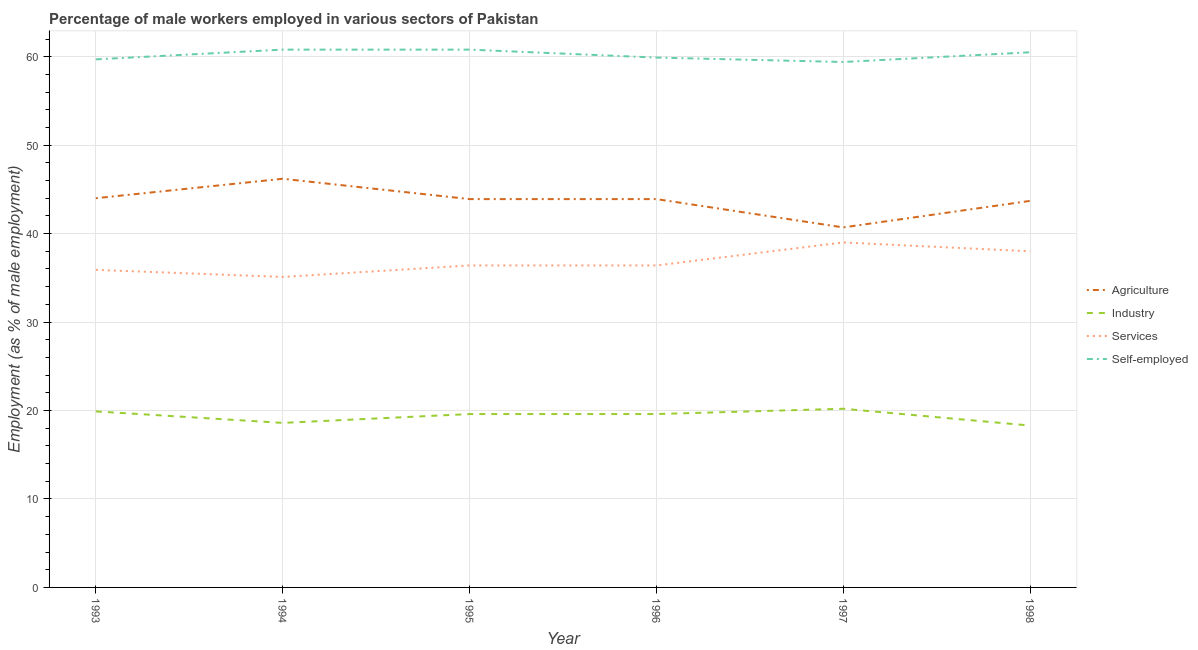Across all years, what is the maximum percentage of male workers in agriculture?
Give a very brief answer. 46.2. Across all years, what is the minimum percentage of self employed male workers?
Provide a succinct answer. 59.4. In which year was the percentage of male workers in services minimum?
Keep it short and to the point. 1994. What is the total percentage of self employed male workers in the graph?
Your answer should be compact. 361.1. What is the difference between the percentage of male workers in services in 1994 and that in 1996?
Provide a succinct answer. -1.3. What is the difference between the percentage of male workers in services in 1997 and the percentage of male workers in agriculture in 1994?
Keep it short and to the point. -7.2. What is the average percentage of male workers in services per year?
Ensure brevity in your answer.  36.8. In the year 1995, what is the difference between the percentage of male workers in industry and percentage of male workers in services?
Offer a terse response. -16.8. What is the ratio of the percentage of male workers in services in 1997 to that in 1998?
Your answer should be compact. 1.03. Is the percentage of male workers in agriculture in 1996 less than that in 1998?
Your answer should be compact. No. Is the difference between the percentage of male workers in services in 1994 and 1998 greater than the difference between the percentage of male workers in industry in 1994 and 1998?
Offer a terse response. No. What is the difference between the highest and the second highest percentage of male workers in industry?
Provide a short and direct response. 0.3. What is the difference between the highest and the lowest percentage of male workers in industry?
Your response must be concise. 1.9. Is the percentage of male workers in services strictly greater than the percentage of male workers in industry over the years?
Your response must be concise. Yes. Does the graph contain grids?
Offer a very short reply. Yes. How many legend labels are there?
Keep it short and to the point. 4. How are the legend labels stacked?
Ensure brevity in your answer.  Vertical. What is the title of the graph?
Give a very brief answer. Percentage of male workers employed in various sectors of Pakistan. What is the label or title of the Y-axis?
Your answer should be compact. Employment (as % of male employment). What is the Employment (as % of male employment) of Agriculture in 1993?
Your answer should be compact. 44. What is the Employment (as % of male employment) of Industry in 1993?
Keep it short and to the point. 19.9. What is the Employment (as % of male employment) in Services in 1993?
Your answer should be very brief. 35.9. What is the Employment (as % of male employment) of Self-employed in 1993?
Your answer should be compact. 59.7. What is the Employment (as % of male employment) of Agriculture in 1994?
Make the answer very short. 46.2. What is the Employment (as % of male employment) of Industry in 1994?
Keep it short and to the point. 18.6. What is the Employment (as % of male employment) in Services in 1994?
Offer a terse response. 35.1. What is the Employment (as % of male employment) in Self-employed in 1994?
Offer a terse response. 60.8. What is the Employment (as % of male employment) of Agriculture in 1995?
Your response must be concise. 43.9. What is the Employment (as % of male employment) in Industry in 1995?
Your answer should be very brief. 19.6. What is the Employment (as % of male employment) of Services in 1995?
Keep it short and to the point. 36.4. What is the Employment (as % of male employment) in Self-employed in 1995?
Offer a terse response. 60.8. What is the Employment (as % of male employment) of Agriculture in 1996?
Your answer should be very brief. 43.9. What is the Employment (as % of male employment) in Industry in 1996?
Your answer should be very brief. 19.6. What is the Employment (as % of male employment) in Services in 1996?
Your answer should be compact. 36.4. What is the Employment (as % of male employment) in Self-employed in 1996?
Give a very brief answer. 59.9. What is the Employment (as % of male employment) of Agriculture in 1997?
Keep it short and to the point. 40.7. What is the Employment (as % of male employment) of Industry in 1997?
Offer a terse response. 20.2. What is the Employment (as % of male employment) of Self-employed in 1997?
Keep it short and to the point. 59.4. What is the Employment (as % of male employment) of Agriculture in 1998?
Provide a short and direct response. 43.7. What is the Employment (as % of male employment) in Industry in 1998?
Make the answer very short. 18.3. What is the Employment (as % of male employment) in Services in 1998?
Offer a very short reply. 38. What is the Employment (as % of male employment) in Self-employed in 1998?
Offer a very short reply. 60.5. Across all years, what is the maximum Employment (as % of male employment) in Agriculture?
Your answer should be very brief. 46.2. Across all years, what is the maximum Employment (as % of male employment) of Industry?
Provide a short and direct response. 20.2. Across all years, what is the maximum Employment (as % of male employment) of Self-employed?
Provide a short and direct response. 60.8. Across all years, what is the minimum Employment (as % of male employment) in Agriculture?
Your answer should be very brief. 40.7. Across all years, what is the minimum Employment (as % of male employment) in Industry?
Make the answer very short. 18.3. Across all years, what is the minimum Employment (as % of male employment) in Services?
Provide a succinct answer. 35.1. Across all years, what is the minimum Employment (as % of male employment) in Self-employed?
Offer a very short reply. 59.4. What is the total Employment (as % of male employment) of Agriculture in the graph?
Your answer should be compact. 262.4. What is the total Employment (as % of male employment) in Industry in the graph?
Make the answer very short. 116.2. What is the total Employment (as % of male employment) of Services in the graph?
Your response must be concise. 220.8. What is the total Employment (as % of male employment) in Self-employed in the graph?
Ensure brevity in your answer.  361.1. What is the difference between the Employment (as % of male employment) in Agriculture in 1993 and that in 1994?
Give a very brief answer. -2.2. What is the difference between the Employment (as % of male employment) of Services in 1993 and that in 1994?
Make the answer very short. 0.8. What is the difference between the Employment (as % of male employment) in Agriculture in 1993 and that in 1995?
Ensure brevity in your answer.  0.1. What is the difference between the Employment (as % of male employment) in Industry in 1993 and that in 1995?
Provide a succinct answer. 0.3. What is the difference between the Employment (as % of male employment) of Services in 1993 and that in 1995?
Your answer should be very brief. -0.5. What is the difference between the Employment (as % of male employment) of Agriculture in 1993 and that in 1996?
Give a very brief answer. 0.1. What is the difference between the Employment (as % of male employment) in Industry in 1993 and that in 1996?
Offer a very short reply. 0.3. What is the difference between the Employment (as % of male employment) in Services in 1993 and that in 1996?
Offer a terse response. -0.5. What is the difference between the Employment (as % of male employment) of Agriculture in 1993 and that in 1997?
Your answer should be compact. 3.3. What is the difference between the Employment (as % of male employment) in Industry in 1993 and that in 1997?
Provide a short and direct response. -0.3. What is the difference between the Employment (as % of male employment) in Industry in 1994 and that in 1995?
Provide a short and direct response. -1. What is the difference between the Employment (as % of male employment) in Industry in 1994 and that in 1996?
Your answer should be compact. -1. What is the difference between the Employment (as % of male employment) in Self-employed in 1994 and that in 1996?
Offer a terse response. 0.9. What is the difference between the Employment (as % of male employment) in Services in 1994 and that in 1997?
Offer a terse response. -3.9. What is the difference between the Employment (as % of male employment) in Self-employed in 1994 and that in 1997?
Provide a short and direct response. 1.4. What is the difference between the Employment (as % of male employment) of Industry in 1994 and that in 1998?
Your answer should be compact. 0.3. What is the difference between the Employment (as % of male employment) in Services in 1994 and that in 1998?
Make the answer very short. -2.9. What is the difference between the Employment (as % of male employment) of Self-employed in 1994 and that in 1998?
Offer a terse response. 0.3. What is the difference between the Employment (as % of male employment) of Agriculture in 1995 and that in 1996?
Make the answer very short. 0. What is the difference between the Employment (as % of male employment) of Agriculture in 1995 and that in 1997?
Your answer should be very brief. 3.2. What is the difference between the Employment (as % of male employment) of Services in 1995 and that in 1997?
Provide a short and direct response. -2.6. What is the difference between the Employment (as % of male employment) in Self-employed in 1995 and that in 1997?
Provide a short and direct response. 1.4. What is the difference between the Employment (as % of male employment) of Agriculture in 1995 and that in 1998?
Offer a terse response. 0.2. What is the difference between the Employment (as % of male employment) of Industry in 1995 and that in 1998?
Give a very brief answer. 1.3. What is the difference between the Employment (as % of male employment) in Self-employed in 1995 and that in 1998?
Make the answer very short. 0.3. What is the difference between the Employment (as % of male employment) of Agriculture in 1996 and that in 1997?
Keep it short and to the point. 3.2. What is the difference between the Employment (as % of male employment) in Industry in 1996 and that in 1997?
Give a very brief answer. -0.6. What is the difference between the Employment (as % of male employment) in Services in 1996 and that in 1997?
Keep it short and to the point. -2.6. What is the difference between the Employment (as % of male employment) of Self-employed in 1996 and that in 1997?
Your response must be concise. 0.5. What is the difference between the Employment (as % of male employment) of Agriculture in 1996 and that in 1998?
Your answer should be very brief. 0.2. What is the difference between the Employment (as % of male employment) in Industry in 1996 and that in 1998?
Keep it short and to the point. 1.3. What is the difference between the Employment (as % of male employment) in Self-employed in 1996 and that in 1998?
Your response must be concise. -0.6. What is the difference between the Employment (as % of male employment) in Agriculture in 1997 and that in 1998?
Your answer should be very brief. -3. What is the difference between the Employment (as % of male employment) of Industry in 1997 and that in 1998?
Your answer should be compact. 1.9. What is the difference between the Employment (as % of male employment) in Self-employed in 1997 and that in 1998?
Ensure brevity in your answer.  -1.1. What is the difference between the Employment (as % of male employment) of Agriculture in 1993 and the Employment (as % of male employment) of Industry in 1994?
Your response must be concise. 25.4. What is the difference between the Employment (as % of male employment) in Agriculture in 1993 and the Employment (as % of male employment) in Services in 1994?
Your answer should be very brief. 8.9. What is the difference between the Employment (as % of male employment) of Agriculture in 1993 and the Employment (as % of male employment) of Self-employed in 1994?
Ensure brevity in your answer.  -16.8. What is the difference between the Employment (as % of male employment) in Industry in 1993 and the Employment (as % of male employment) in Services in 1994?
Provide a short and direct response. -15.2. What is the difference between the Employment (as % of male employment) in Industry in 1993 and the Employment (as % of male employment) in Self-employed in 1994?
Keep it short and to the point. -40.9. What is the difference between the Employment (as % of male employment) in Services in 1993 and the Employment (as % of male employment) in Self-employed in 1994?
Offer a very short reply. -24.9. What is the difference between the Employment (as % of male employment) of Agriculture in 1993 and the Employment (as % of male employment) of Industry in 1995?
Give a very brief answer. 24.4. What is the difference between the Employment (as % of male employment) of Agriculture in 1993 and the Employment (as % of male employment) of Self-employed in 1995?
Make the answer very short. -16.8. What is the difference between the Employment (as % of male employment) in Industry in 1993 and the Employment (as % of male employment) in Services in 1995?
Provide a succinct answer. -16.5. What is the difference between the Employment (as % of male employment) of Industry in 1993 and the Employment (as % of male employment) of Self-employed in 1995?
Offer a terse response. -40.9. What is the difference between the Employment (as % of male employment) of Services in 1993 and the Employment (as % of male employment) of Self-employed in 1995?
Provide a short and direct response. -24.9. What is the difference between the Employment (as % of male employment) in Agriculture in 1993 and the Employment (as % of male employment) in Industry in 1996?
Provide a short and direct response. 24.4. What is the difference between the Employment (as % of male employment) in Agriculture in 1993 and the Employment (as % of male employment) in Services in 1996?
Keep it short and to the point. 7.6. What is the difference between the Employment (as % of male employment) in Agriculture in 1993 and the Employment (as % of male employment) in Self-employed in 1996?
Offer a very short reply. -15.9. What is the difference between the Employment (as % of male employment) in Industry in 1993 and the Employment (as % of male employment) in Services in 1996?
Ensure brevity in your answer.  -16.5. What is the difference between the Employment (as % of male employment) in Industry in 1993 and the Employment (as % of male employment) in Self-employed in 1996?
Your response must be concise. -40. What is the difference between the Employment (as % of male employment) of Agriculture in 1993 and the Employment (as % of male employment) of Industry in 1997?
Keep it short and to the point. 23.8. What is the difference between the Employment (as % of male employment) in Agriculture in 1993 and the Employment (as % of male employment) in Services in 1997?
Give a very brief answer. 5. What is the difference between the Employment (as % of male employment) in Agriculture in 1993 and the Employment (as % of male employment) in Self-employed in 1997?
Your answer should be very brief. -15.4. What is the difference between the Employment (as % of male employment) in Industry in 1993 and the Employment (as % of male employment) in Services in 1997?
Give a very brief answer. -19.1. What is the difference between the Employment (as % of male employment) of Industry in 1993 and the Employment (as % of male employment) of Self-employed in 1997?
Keep it short and to the point. -39.5. What is the difference between the Employment (as % of male employment) of Services in 1993 and the Employment (as % of male employment) of Self-employed in 1997?
Your answer should be very brief. -23.5. What is the difference between the Employment (as % of male employment) in Agriculture in 1993 and the Employment (as % of male employment) in Industry in 1998?
Your answer should be compact. 25.7. What is the difference between the Employment (as % of male employment) of Agriculture in 1993 and the Employment (as % of male employment) of Services in 1998?
Your answer should be very brief. 6. What is the difference between the Employment (as % of male employment) in Agriculture in 1993 and the Employment (as % of male employment) in Self-employed in 1998?
Make the answer very short. -16.5. What is the difference between the Employment (as % of male employment) of Industry in 1993 and the Employment (as % of male employment) of Services in 1998?
Ensure brevity in your answer.  -18.1. What is the difference between the Employment (as % of male employment) in Industry in 1993 and the Employment (as % of male employment) in Self-employed in 1998?
Make the answer very short. -40.6. What is the difference between the Employment (as % of male employment) of Services in 1993 and the Employment (as % of male employment) of Self-employed in 1998?
Keep it short and to the point. -24.6. What is the difference between the Employment (as % of male employment) in Agriculture in 1994 and the Employment (as % of male employment) in Industry in 1995?
Offer a terse response. 26.6. What is the difference between the Employment (as % of male employment) in Agriculture in 1994 and the Employment (as % of male employment) in Services in 1995?
Your response must be concise. 9.8. What is the difference between the Employment (as % of male employment) of Agriculture in 1994 and the Employment (as % of male employment) of Self-employed in 1995?
Provide a succinct answer. -14.6. What is the difference between the Employment (as % of male employment) in Industry in 1994 and the Employment (as % of male employment) in Services in 1995?
Provide a short and direct response. -17.8. What is the difference between the Employment (as % of male employment) in Industry in 1994 and the Employment (as % of male employment) in Self-employed in 1995?
Provide a short and direct response. -42.2. What is the difference between the Employment (as % of male employment) in Services in 1994 and the Employment (as % of male employment) in Self-employed in 1995?
Offer a terse response. -25.7. What is the difference between the Employment (as % of male employment) of Agriculture in 1994 and the Employment (as % of male employment) of Industry in 1996?
Offer a terse response. 26.6. What is the difference between the Employment (as % of male employment) of Agriculture in 1994 and the Employment (as % of male employment) of Self-employed in 1996?
Your response must be concise. -13.7. What is the difference between the Employment (as % of male employment) of Industry in 1994 and the Employment (as % of male employment) of Services in 1996?
Make the answer very short. -17.8. What is the difference between the Employment (as % of male employment) in Industry in 1994 and the Employment (as % of male employment) in Self-employed in 1996?
Offer a terse response. -41.3. What is the difference between the Employment (as % of male employment) of Services in 1994 and the Employment (as % of male employment) of Self-employed in 1996?
Offer a terse response. -24.8. What is the difference between the Employment (as % of male employment) in Agriculture in 1994 and the Employment (as % of male employment) in Services in 1997?
Offer a very short reply. 7.2. What is the difference between the Employment (as % of male employment) of Agriculture in 1994 and the Employment (as % of male employment) of Self-employed in 1997?
Your answer should be very brief. -13.2. What is the difference between the Employment (as % of male employment) in Industry in 1994 and the Employment (as % of male employment) in Services in 1997?
Offer a terse response. -20.4. What is the difference between the Employment (as % of male employment) in Industry in 1994 and the Employment (as % of male employment) in Self-employed in 1997?
Your answer should be very brief. -40.8. What is the difference between the Employment (as % of male employment) of Services in 1994 and the Employment (as % of male employment) of Self-employed in 1997?
Make the answer very short. -24.3. What is the difference between the Employment (as % of male employment) in Agriculture in 1994 and the Employment (as % of male employment) in Industry in 1998?
Your response must be concise. 27.9. What is the difference between the Employment (as % of male employment) of Agriculture in 1994 and the Employment (as % of male employment) of Self-employed in 1998?
Ensure brevity in your answer.  -14.3. What is the difference between the Employment (as % of male employment) of Industry in 1994 and the Employment (as % of male employment) of Services in 1998?
Your response must be concise. -19.4. What is the difference between the Employment (as % of male employment) in Industry in 1994 and the Employment (as % of male employment) in Self-employed in 1998?
Keep it short and to the point. -41.9. What is the difference between the Employment (as % of male employment) of Services in 1994 and the Employment (as % of male employment) of Self-employed in 1998?
Your answer should be compact. -25.4. What is the difference between the Employment (as % of male employment) of Agriculture in 1995 and the Employment (as % of male employment) of Industry in 1996?
Offer a very short reply. 24.3. What is the difference between the Employment (as % of male employment) of Agriculture in 1995 and the Employment (as % of male employment) of Services in 1996?
Your answer should be very brief. 7.5. What is the difference between the Employment (as % of male employment) in Industry in 1995 and the Employment (as % of male employment) in Services in 1996?
Your answer should be compact. -16.8. What is the difference between the Employment (as % of male employment) of Industry in 1995 and the Employment (as % of male employment) of Self-employed in 1996?
Offer a very short reply. -40.3. What is the difference between the Employment (as % of male employment) in Services in 1995 and the Employment (as % of male employment) in Self-employed in 1996?
Make the answer very short. -23.5. What is the difference between the Employment (as % of male employment) of Agriculture in 1995 and the Employment (as % of male employment) of Industry in 1997?
Keep it short and to the point. 23.7. What is the difference between the Employment (as % of male employment) of Agriculture in 1995 and the Employment (as % of male employment) of Services in 1997?
Keep it short and to the point. 4.9. What is the difference between the Employment (as % of male employment) in Agriculture in 1995 and the Employment (as % of male employment) in Self-employed in 1997?
Your response must be concise. -15.5. What is the difference between the Employment (as % of male employment) in Industry in 1995 and the Employment (as % of male employment) in Services in 1997?
Your response must be concise. -19.4. What is the difference between the Employment (as % of male employment) in Industry in 1995 and the Employment (as % of male employment) in Self-employed in 1997?
Make the answer very short. -39.8. What is the difference between the Employment (as % of male employment) in Agriculture in 1995 and the Employment (as % of male employment) in Industry in 1998?
Provide a short and direct response. 25.6. What is the difference between the Employment (as % of male employment) of Agriculture in 1995 and the Employment (as % of male employment) of Services in 1998?
Offer a terse response. 5.9. What is the difference between the Employment (as % of male employment) in Agriculture in 1995 and the Employment (as % of male employment) in Self-employed in 1998?
Keep it short and to the point. -16.6. What is the difference between the Employment (as % of male employment) of Industry in 1995 and the Employment (as % of male employment) of Services in 1998?
Your response must be concise. -18.4. What is the difference between the Employment (as % of male employment) in Industry in 1995 and the Employment (as % of male employment) in Self-employed in 1998?
Ensure brevity in your answer.  -40.9. What is the difference between the Employment (as % of male employment) in Services in 1995 and the Employment (as % of male employment) in Self-employed in 1998?
Provide a succinct answer. -24.1. What is the difference between the Employment (as % of male employment) of Agriculture in 1996 and the Employment (as % of male employment) of Industry in 1997?
Your answer should be compact. 23.7. What is the difference between the Employment (as % of male employment) of Agriculture in 1996 and the Employment (as % of male employment) of Services in 1997?
Provide a short and direct response. 4.9. What is the difference between the Employment (as % of male employment) of Agriculture in 1996 and the Employment (as % of male employment) of Self-employed in 1997?
Provide a succinct answer. -15.5. What is the difference between the Employment (as % of male employment) in Industry in 1996 and the Employment (as % of male employment) in Services in 1997?
Provide a short and direct response. -19.4. What is the difference between the Employment (as % of male employment) of Industry in 1996 and the Employment (as % of male employment) of Self-employed in 1997?
Keep it short and to the point. -39.8. What is the difference between the Employment (as % of male employment) in Services in 1996 and the Employment (as % of male employment) in Self-employed in 1997?
Keep it short and to the point. -23. What is the difference between the Employment (as % of male employment) of Agriculture in 1996 and the Employment (as % of male employment) of Industry in 1998?
Your answer should be compact. 25.6. What is the difference between the Employment (as % of male employment) in Agriculture in 1996 and the Employment (as % of male employment) in Self-employed in 1998?
Make the answer very short. -16.6. What is the difference between the Employment (as % of male employment) in Industry in 1996 and the Employment (as % of male employment) in Services in 1998?
Your answer should be compact. -18.4. What is the difference between the Employment (as % of male employment) in Industry in 1996 and the Employment (as % of male employment) in Self-employed in 1998?
Ensure brevity in your answer.  -40.9. What is the difference between the Employment (as % of male employment) of Services in 1996 and the Employment (as % of male employment) of Self-employed in 1998?
Your answer should be compact. -24.1. What is the difference between the Employment (as % of male employment) in Agriculture in 1997 and the Employment (as % of male employment) in Industry in 1998?
Your answer should be very brief. 22.4. What is the difference between the Employment (as % of male employment) of Agriculture in 1997 and the Employment (as % of male employment) of Services in 1998?
Provide a succinct answer. 2.7. What is the difference between the Employment (as % of male employment) of Agriculture in 1997 and the Employment (as % of male employment) of Self-employed in 1998?
Offer a terse response. -19.8. What is the difference between the Employment (as % of male employment) of Industry in 1997 and the Employment (as % of male employment) of Services in 1998?
Give a very brief answer. -17.8. What is the difference between the Employment (as % of male employment) of Industry in 1997 and the Employment (as % of male employment) of Self-employed in 1998?
Your response must be concise. -40.3. What is the difference between the Employment (as % of male employment) in Services in 1997 and the Employment (as % of male employment) in Self-employed in 1998?
Give a very brief answer. -21.5. What is the average Employment (as % of male employment) in Agriculture per year?
Offer a very short reply. 43.73. What is the average Employment (as % of male employment) in Industry per year?
Your answer should be very brief. 19.37. What is the average Employment (as % of male employment) of Services per year?
Offer a terse response. 36.8. What is the average Employment (as % of male employment) in Self-employed per year?
Your answer should be very brief. 60.18. In the year 1993, what is the difference between the Employment (as % of male employment) in Agriculture and Employment (as % of male employment) in Industry?
Give a very brief answer. 24.1. In the year 1993, what is the difference between the Employment (as % of male employment) in Agriculture and Employment (as % of male employment) in Services?
Your answer should be compact. 8.1. In the year 1993, what is the difference between the Employment (as % of male employment) of Agriculture and Employment (as % of male employment) of Self-employed?
Offer a very short reply. -15.7. In the year 1993, what is the difference between the Employment (as % of male employment) in Industry and Employment (as % of male employment) in Services?
Ensure brevity in your answer.  -16. In the year 1993, what is the difference between the Employment (as % of male employment) in Industry and Employment (as % of male employment) in Self-employed?
Provide a succinct answer. -39.8. In the year 1993, what is the difference between the Employment (as % of male employment) of Services and Employment (as % of male employment) of Self-employed?
Your answer should be compact. -23.8. In the year 1994, what is the difference between the Employment (as % of male employment) in Agriculture and Employment (as % of male employment) in Industry?
Your answer should be compact. 27.6. In the year 1994, what is the difference between the Employment (as % of male employment) in Agriculture and Employment (as % of male employment) in Services?
Give a very brief answer. 11.1. In the year 1994, what is the difference between the Employment (as % of male employment) of Agriculture and Employment (as % of male employment) of Self-employed?
Your answer should be compact. -14.6. In the year 1994, what is the difference between the Employment (as % of male employment) in Industry and Employment (as % of male employment) in Services?
Provide a succinct answer. -16.5. In the year 1994, what is the difference between the Employment (as % of male employment) in Industry and Employment (as % of male employment) in Self-employed?
Offer a terse response. -42.2. In the year 1994, what is the difference between the Employment (as % of male employment) of Services and Employment (as % of male employment) of Self-employed?
Your answer should be compact. -25.7. In the year 1995, what is the difference between the Employment (as % of male employment) of Agriculture and Employment (as % of male employment) of Industry?
Keep it short and to the point. 24.3. In the year 1995, what is the difference between the Employment (as % of male employment) of Agriculture and Employment (as % of male employment) of Services?
Your response must be concise. 7.5. In the year 1995, what is the difference between the Employment (as % of male employment) in Agriculture and Employment (as % of male employment) in Self-employed?
Offer a terse response. -16.9. In the year 1995, what is the difference between the Employment (as % of male employment) of Industry and Employment (as % of male employment) of Services?
Your answer should be very brief. -16.8. In the year 1995, what is the difference between the Employment (as % of male employment) of Industry and Employment (as % of male employment) of Self-employed?
Provide a succinct answer. -41.2. In the year 1995, what is the difference between the Employment (as % of male employment) of Services and Employment (as % of male employment) of Self-employed?
Provide a succinct answer. -24.4. In the year 1996, what is the difference between the Employment (as % of male employment) of Agriculture and Employment (as % of male employment) of Industry?
Keep it short and to the point. 24.3. In the year 1996, what is the difference between the Employment (as % of male employment) of Industry and Employment (as % of male employment) of Services?
Provide a succinct answer. -16.8. In the year 1996, what is the difference between the Employment (as % of male employment) in Industry and Employment (as % of male employment) in Self-employed?
Your answer should be compact. -40.3. In the year 1996, what is the difference between the Employment (as % of male employment) of Services and Employment (as % of male employment) of Self-employed?
Ensure brevity in your answer.  -23.5. In the year 1997, what is the difference between the Employment (as % of male employment) of Agriculture and Employment (as % of male employment) of Services?
Make the answer very short. 1.7. In the year 1997, what is the difference between the Employment (as % of male employment) of Agriculture and Employment (as % of male employment) of Self-employed?
Ensure brevity in your answer.  -18.7. In the year 1997, what is the difference between the Employment (as % of male employment) in Industry and Employment (as % of male employment) in Services?
Make the answer very short. -18.8. In the year 1997, what is the difference between the Employment (as % of male employment) of Industry and Employment (as % of male employment) of Self-employed?
Provide a succinct answer. -39.2. In the year 1997, what is the difference between the Employment (as % of male employment) of Services and Employment (as % of male employment) of Self-employed?
Offer a very short reply. -20.4. In the year 1998, what is the difference between the Employment (as % of male employment) of Agriculture and Employment (as % of male employment) of Industry?
Offer a very short reply. 25.4. In the year 1998, what is the difference between the Employment (as % of male employment) in Agriculture and Employment (as % of male employment) in Services?
Provide a succinct answer. 5.7. In the year 1998, what is the difference between the Employment (as % of male employment) in Agriculture and Employment (as % of male employment) in Self-employed?
Provide a succinct answer. -16.8. In the year 1998, what is the difference between the Employment (as % of male employment) in Industry and Employment (as % of male employment) in Services?
Ensure brevity in your answer.  -19.7. In the year 1998, what is the difference between the Employment (as % of male employment) in Industry and Employment (as % of male employment) in Self-employed?
Your response must be concise. -42.2. In the year 1998, what is the difference between the Employment (as % of male employment) of Services and Employment (as % of male employment) of Self-employed?
Provide a short and direct response. -22.5. What is the ratio of the Employment (as % of male employment) in Industry in 1993 to that in 1994?
Your answer should be very brief. 1.07. What is the ratio of the Employment (as % of male employment) of Services in 1993 to that in 1994?
Keep it short and to the point. 1.02. What is the ratio of the Employment (as % of male employment) in Self-employed in 1993 to that in 1994?
Keep it short and to the point. 0.98. What is the ratio of the Employment (as % of male employment) of Agriculture in 1993 to that in 1995?
Keep it short and to the point. 1. What is the ratio of the Employment (as % of male employment) of Industry in 1993 to that in 1995?
Your answer should be compact. 1.02. What is the ratio of the Employment (as % of male employment) of Services in 1993 to that in 1995?
Your answer should be very brief. 0.99. What is the ratio of the Employment (as % of male employment) in Self-employed in 1993 to that in 1995?
Your response must be concise. 0.98. What is the ratio of the Employment (as % of male employment) of Industry in 1993 to that in 1996?
Ensure brevity in your answer.  1.02. What is the ratio of the Employment (as % of male employment) in Services in 1993 to that in 1996?
Give a very brief answer. 0.99. What is the ratio of the Employment (as % of male employment) of Self-employed in 1993 to that in 1996?
Give a very brief answer. 1. What is the ratio of the Employment (as % of male employment) of Agriculture in 1993 to that in 1997?
Your answer should be very brief. 1.08. What is the ratio of the Employment (as % of male employment) in Industry in 1993 to that in 1997?
Provide a short and direct response. 0.99. What is the ratio of the Employment (as % of male employment) of Services in 1993 to that in 1997?
Keep it short and to the point. 0.92. What is the ratio of the Employment (as % of male employment) in Agriculture in 1993 to that in 1998?
Provide a succinct answer. 1.01. What is the ratio of the Employment (as % of male employment) in Industry in 1993 to that in 1998?
Give a very brief answer. 1.09. What is the ratio of the Employment (as % of male employment) of Services in 1993 to that in 1998?
Provide a succinct answer. 0.94. What is the ratio of the Employment (as % of male employment) in Agriculture in 1994 to that in 1995?
Your response must be concise. 1.05. What is the ratio of the Employment (as % of male employment) of Industry in 1994 to that in 1995?
Your response must be concise. 0.95. What is the ratio of the Employment (as % of male employment) of Self-employed in 1994 to that in 1995?
Your answer should be very brief. 1. What is the ratio of the Employment (as % of male employment) of Agriculture in 1994 to that in 1996?
Provide a succinct answer. 1.05. What is the ratio of the Employment (as % of male employment) of Industry in 1994 to that in 1996?
Provide a short and direct response. 0.95. What is the ratio of the Employment (as % of male employment) of Self-employed in 1994 to that in 1996?
Make the answer very short. 1.01. What is the ratio of the Employment (as % of male employment) of Agriculture in 1994 to that in 1997?
Offer a terse response. 1.14. What is the ratio of the Employment (as % of male employment) in Industry in 1994 to that in 1997?
Offer a terse response. 0.92. What is the ratio of the Employment (as % of male employment) in Services in 1994 to that in 1997?
Provide a short and direct response. 0.9. What is the ratio of the Employment (as % of male employment) in Self-employed in 1994 to that in 1997?
Offer a terse response. 1.02. What is the ratio of the Employment (as % of male employment) in Agriculture in 1994 to that in 1998?
Make the answer very short. 1.06. What is the ratio of the Employment (as % of male employment) in Industry in 1994 to that in 1998?
Make the answer very short. 1.02. What is the ratio of the Employment (as % of male employment) in Services in 1994 to that in 1998?
Provide a succinct answer. 0.92. What is the ratio of the Employment (as % of male employment) in Self-employed in 1994 to that in 1998?
Provide a short and direct response. 1. What is the ratio of the Employment (as % of male employment) in Agriculture in 1995 to that in 1996?
Provide a succinct answer. 1. What is the ratio of the Employment (as % of male employment) in Industry in 1995 to that in 1996?
Keep it short and to the point. 1. What is the ratio of the Employment (as % of male employment) in Self-employed in 1995 to that in 1996?
Give a very brief answer. 1.01. What is the ratio of the Employment (as % of male employment) of Agriculture in 1995 to that in 1997?
Your answer should be compact. 1.08. What is the ratio of the Employment (as % of male employment) in Industry in 1995 to that in 1997?
Offer a terse response. 0.97. What is the ratio of the Employment (as % of male employment) in Self-employed in 1995 to that in 1997?
Your response must be concise. 1.02. What is the ratio of the Employment (as % of male employment) of Agriculture in 1995 to that in 1998?
Make the answer very short. 1. What is the ratio of the Employment (as % of male employment) of Industry in 1995 to that in 1998?
Provide a short and direct response. 1.07. What is the ratio of the Employment (as % of male employment) in Services in 1995 to that in 1998?
Your response must be concise. 0.96. What is the ratio of the Employment (as % of male employment) of Agriculture in 1996 to that in 1997?
Your response must be concise. 1.08. What is the ratio of the Employment (as % of male employment) of Industry in 1996 to that in 1997?
Your answer should be compact. 0.97. What is the ratio of the Employment (as % of male employment) in Services in 1996 to that in 1997?
Give a very brief answer. 0.93. What is the ratio of the Employment (as % of male employment) of Self-employed in 1996 to that in 1997?
Provide a succinct answer. 1.01. What is the ratio of the Employment (as % of male employment) in Agriculture in 1996 to that in 1998?
Ensure brevity in your answer.  1. What is the ratio of the Employment (as % of male employment) in Industry in 1996 to that in 1998?
Your response must be concise. 1.07. What is the ratio of the Employment (as % of male employment) in Services in 1996 to that in 1998?
Your response must be concise. 0.96. What is the ratio of the Employment (as % of male employment) in Self-employed in 1996 to that in 1998?
Your response must be concise. 0.99. What is the ratio of the Employment (as % of male employment) in Agriculture in 1997 to that in 1998?
Offer a terse response. 0.93. What is the ratio of the Employment (as % of male employment) in Industry in 1997 to that in 1998?
Your response must be concise. 1.1. What is the ratio of the Employment (as % of male employment) of Services in 1997 to that in 1998?
Offer a terse response. 1.03. What is the ratio of the Employment (as % of male employment) in Self-employed in 1997 to that in 1998?
Give a very brief answer. 0.98. What is the difference between the highest and the second highest Employment (as % of male employment) of Agriculture?
Provide a succinct answer. 2.2. What is the difference between the highest and the second highest Employment (as % of male employment) in Services?
Offer a very short reply. 1. What is the difference between the highest and the lowest Employment (as % of male employment) in Self-employed?
Your answer should be compact. 1.4. 